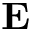<formula> <loc_0><loc_0><loc_500><loc_500>E</formula> 